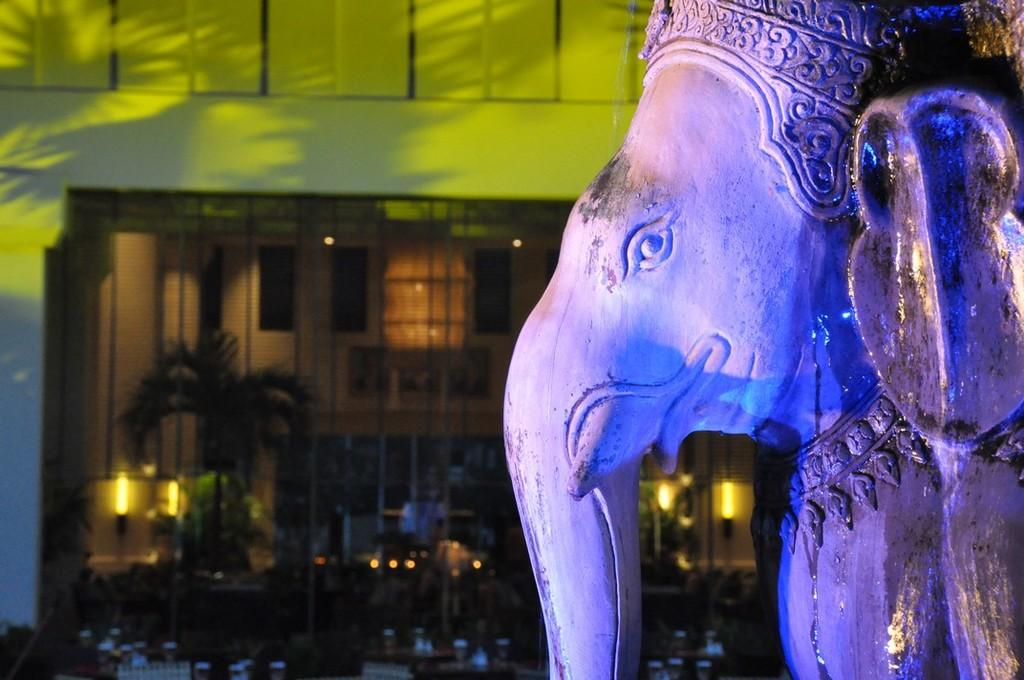What is the main subject of the image? There is a statue of Lord Ganesha in the image. Where is the statue located in the image? The statue is on the left side of the image. What else can be seen in the image besides the statue? There is a building in the image. What type of shoes is Lord Ganesha wearing in the image? Lord Ganesha is a statue and does not have feet or shoes in the image. 